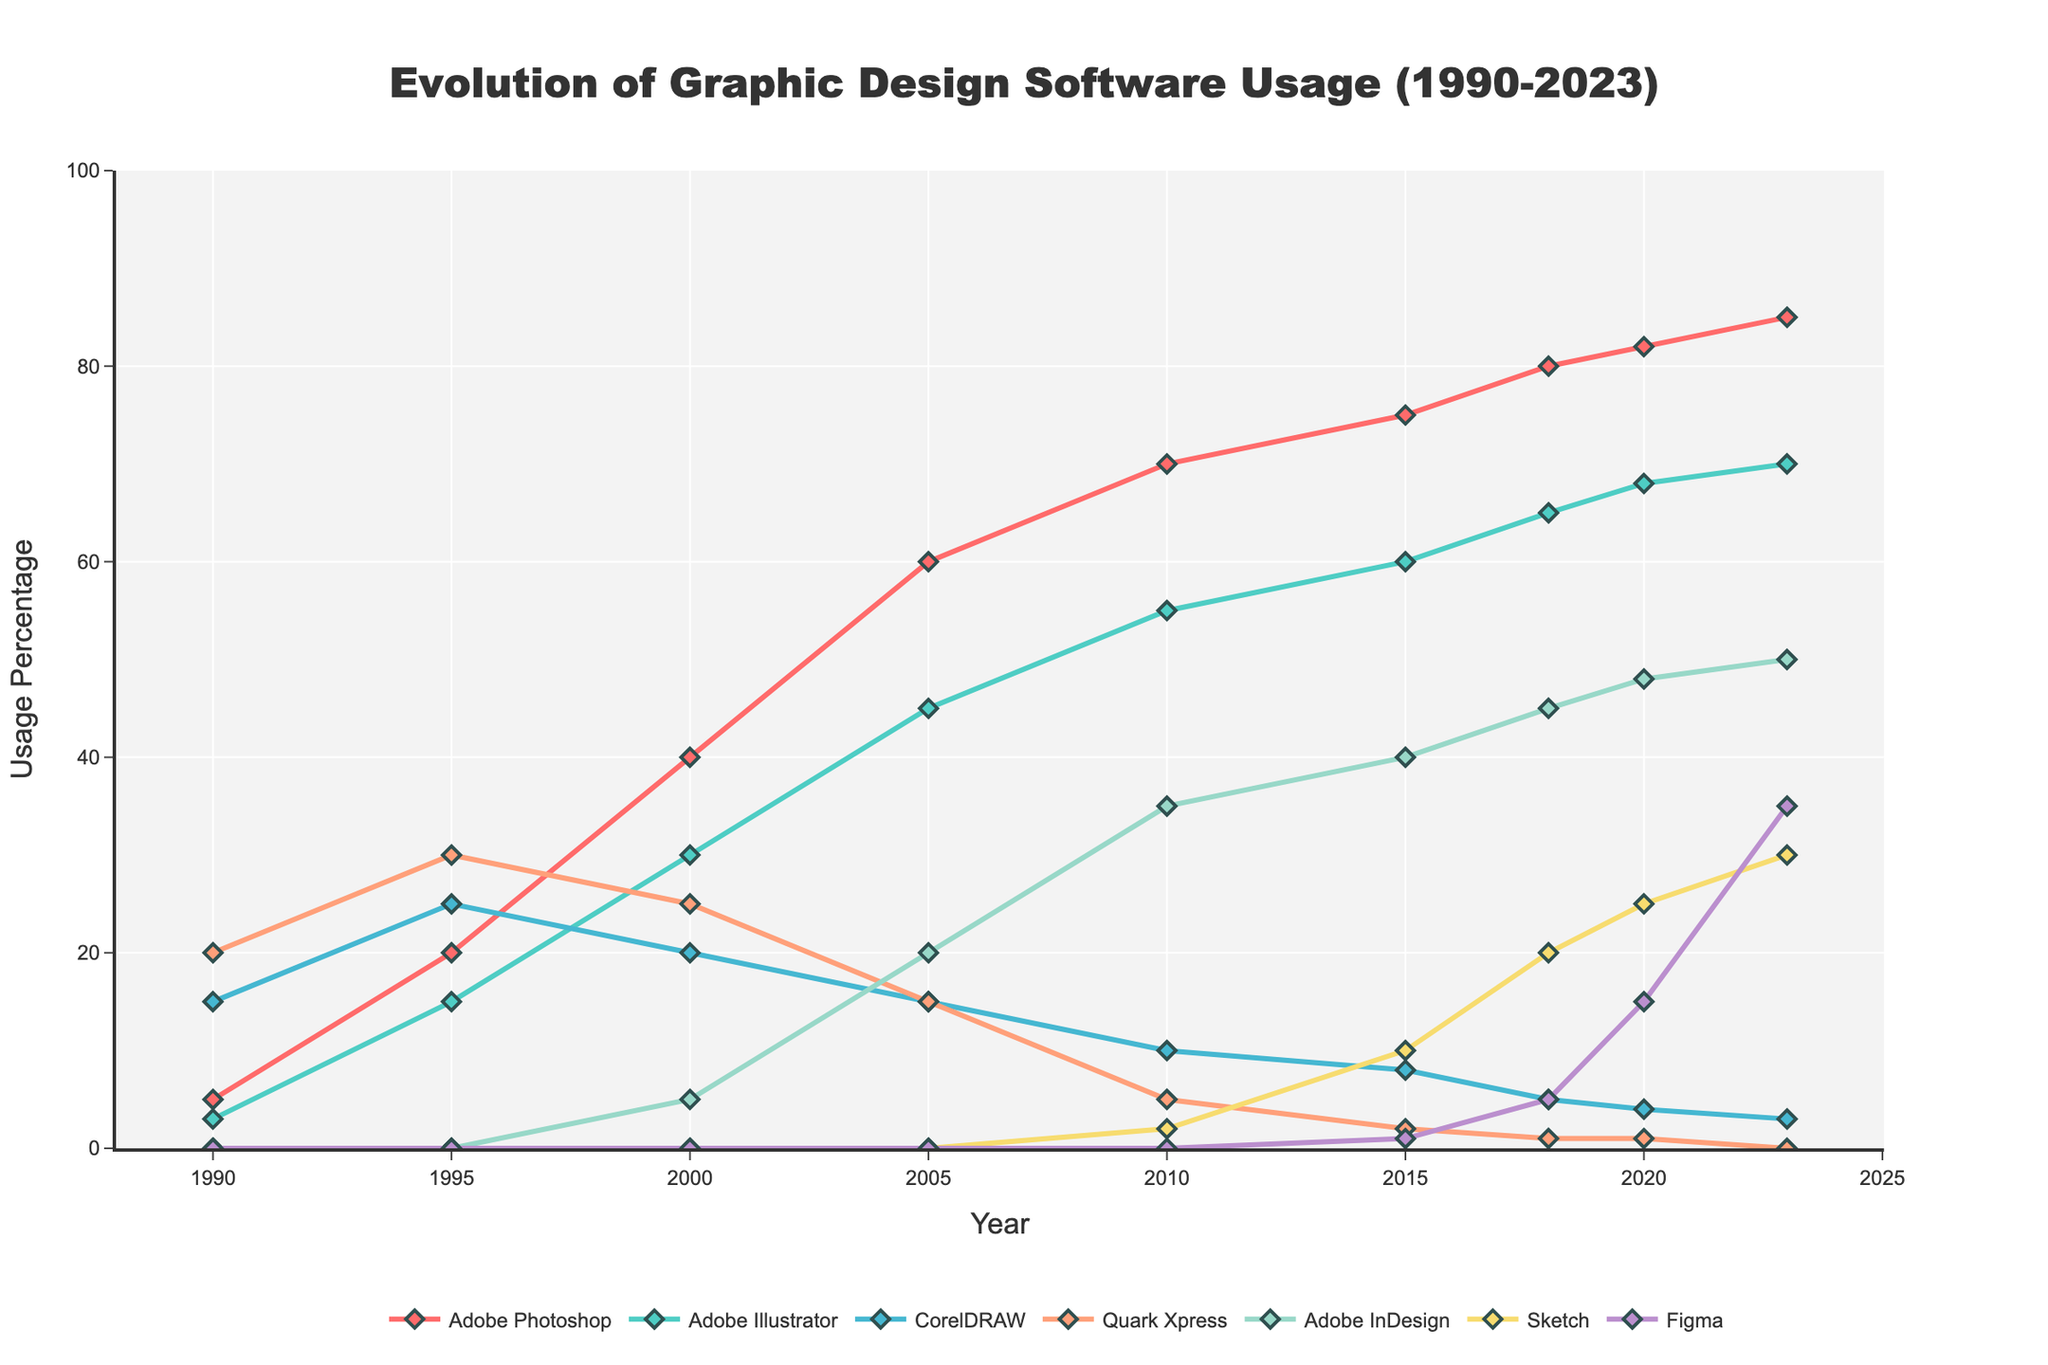Which software had the highest usage in 1990? From the figure, the software with the highest usage percentage in 1990 has the tallest line, which is Quark Xpress.
Answer: Quark Xpress Between Adobe Photoshop and Adobe Illustrator, which software experienced a greater increase in usage percentage from 1990 to 2000? From 1990 to 2000, Adobe Photoshop increased from 5% to 40%, an increase of 35%. Adobe Illustrator increased from 3% to 30%, an increase of 27%. Adobe Photoshop had a greater increase.
Answer: Adobe Photoshop What is the difference in usage between Adobe InDesign and CorelDRAW in 2023? In 2023, Adobe InDesign has a usage percentage of 50% and CorelDRAW has a usage percentage of 3%. The difference is 50% - 3% = 47%.
Answer: 47% List the software whose usage dropped to 0% by 2023. From the figure, the line representing Quark Xpress reaches 0% in 2023.
Answer: Quark Xpress Which software had consistent growth in usage from 2010 to 2023? The figure shows that Figma's usage consistently increases from 0% in 2010 to 35% in 2023.
Answer: Figma In which year did Adobe InDesign surpass Quark Xpress in usage? From the figure, Adobe InDesign surpasses Quark Xpress between 2005 and 2010; during those years, Adobe InDesign's line crosses above Quark Xpress's line. This occurs at 2010.
Answer: 2010 How does the usage trend of Adobe Illustrator between 1990 and 2023 compare to that of Sketch? Adobe Illustrator's usage shows a steady increase from 1990 to 2023, while Sketch's usage starts at 0% in 1990, showing growth after 2010. Overall, Adobe Illustrator has a more consistent and earlier rise.
Answer: Adobe Illustrator shows a steady increase What is the sum of the usage percentages for CorelDRAW and Figma in 2020? In 2020, CorelDRAW has a usage percentage of 4%, and Figma has a usage percentage of 15%. The sum is 4% + 15% = 19%.
Answer: 19% Which software had a usage percentage closest to 50% in 2023? Referring to the figure, Adobe InDesign's usage percentage in 2023 is closest to 50%.
Answer: Adobe InDesign What is the average usage percentage of Adobe Photoshop from 1990 to 2023? The average is calculated by summing the usage percentages (5, 20, 40, 60, 70, 75, 80, 82, 85) and dividing by the number of data points (9). The sum is 517; thus, the average is 517 / 9 ≈ 57.4.
Answer: 57.4 